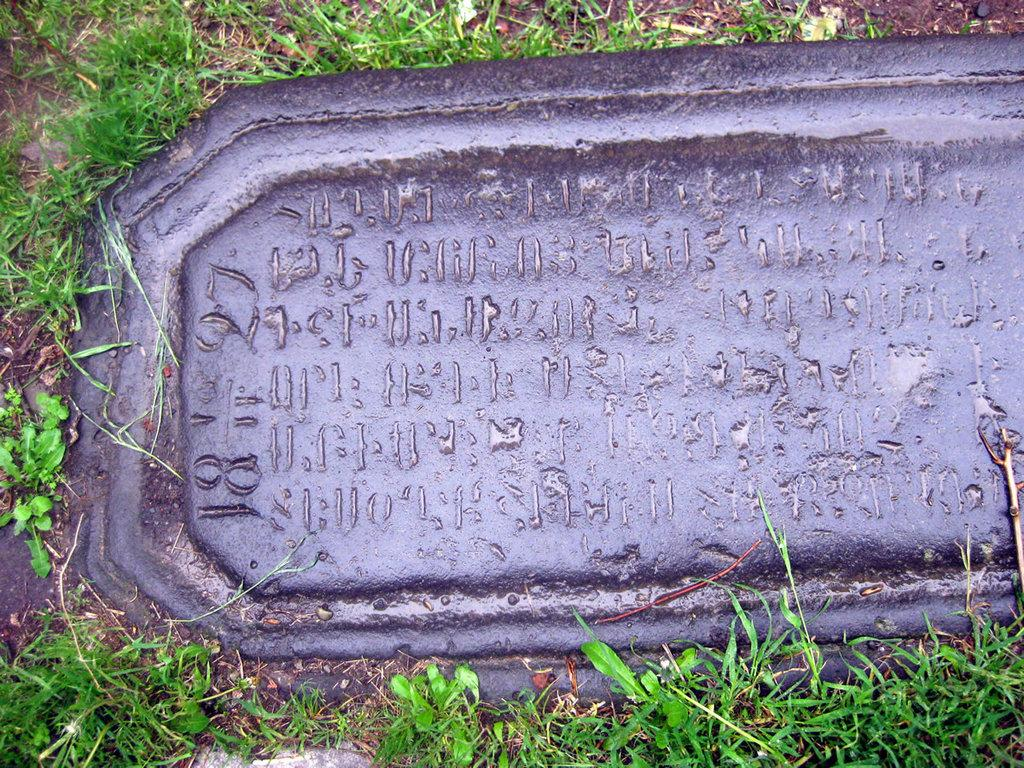What object is present in the image that is made of stone? There is a stone in the image. What is featured on the stone? There is text on the stone. What type of vegetation can be seen on the ground in the image? There is grass on the ground in the image. What type of pen is being used to write the text on the stone in the image? There is no pen present in the image, as the text on the stone is likely engraved or painted on. What type of amusement can be seen in the image? There is no amusement present in the image; it features a stone with text and grass on the ground. 